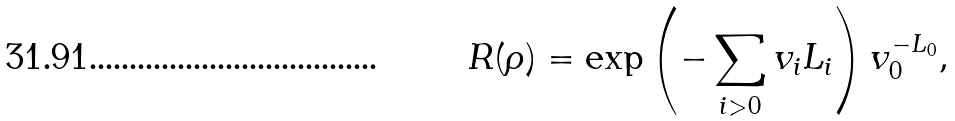<formula> <loc_0><loc_0><loc_500><loc_500>R ( \rho ) = \exp \left ( - \sum _ { i > 0 } v _ { i } L _ { i } \right ) v _ { 0 } ^ { - L _ { 0 } } ,</formula> 